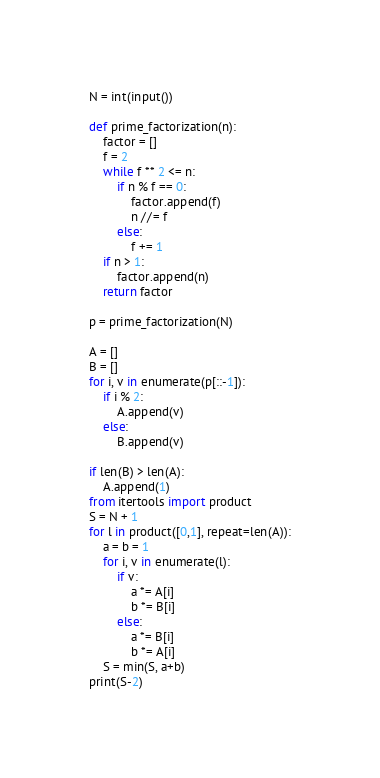<code> <loc_0><loc_0><loc_500><loc_500><_Python_>N = int(input())

def prime_factorization(n):
    factor = []
    f = 2
    while f ** 2 <= n:
        if n % f == 0:
            factor.append(f)
            n //= f
        else:
            f += 1
    if n > 1:
        factor.append(n)
    return factor

p = prime_factorization(N)

A = []
B = []
for i, v in enumerate(p[::-1]):
    if i % 2:
        A.append(v)
    else:
        B.append(v)

if len(B) > len(A):
    A.append(1)
from itertools import product
S = N + 1
for l in product([0,1], repeat=len(A)):
    a = b = 1
    for i, v in enumerate(l):
        if v:
            a *= A[i]
            b *= B[i]
        else:
            a *= B[i]
            b *= A[i]
    S = min(S, a+b)
print(S-2)</code> 